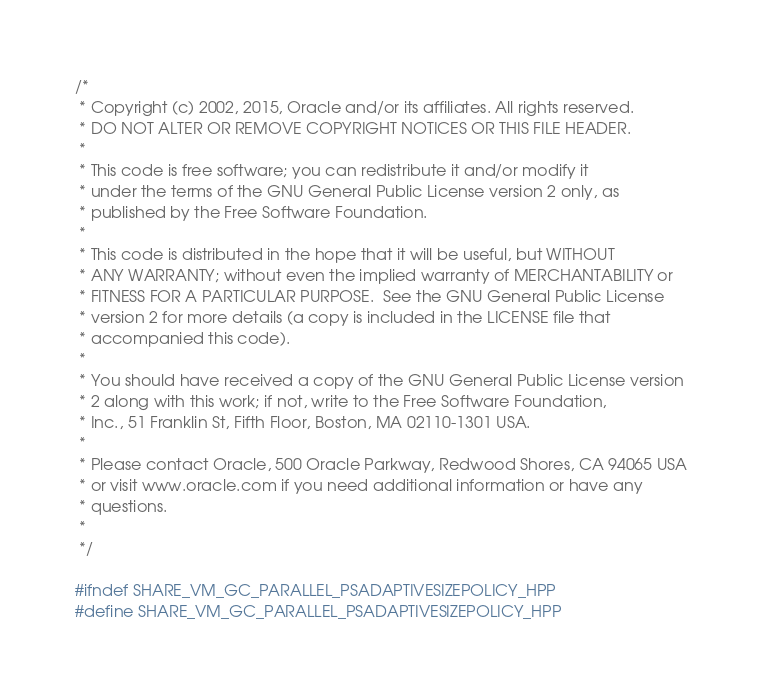<code> <loc_0><loc_0><loc_500><loc_500><_C++_>/*
 * Copyright (c) 2002, 2015, Oracle and/or its affiliates. All rights reserved.
 * DO NOT ALTER OR REMOVE COPYRIGHT NOTICES OR THIS FILE HEADER.
 *
 * This code is free software; you can redistribute it and/or modify it
 * under the terms of the GNU General Public License version 2 only, as
 * published by the Free Software Foundation.
 *
 * This code is distributed in the hope that it will be useful, but WITHOUT
 * ANY WARRANTY; without even the implied warranty of MERCHANTABILITY or
 * FITNESS FOR A PARTICULAR PURPOSE.  See the GNU General Public License
 * version 2 for more details (a copy is included in the LICENSE file that
 * accompanied this code).
 *
 * You should have received a copy of the GNU General Public License version
 * 2 along with this work; if not, write to the Free Software Foundation,
 * Inc., 51 Franklin St, Fifth Floor, Boston, MA 02110-1301 USA.
 *
 * Please contact Oracle, 500 Oracle Parkway, Redwood Shores, CA 94065 USA
 * or visit www.oracle.com if you need additional information or have any
 * questions.
 *
 */

#ifndef SHARE_VM_GC_PARALLEL_PSADAPTIVESIZEPOLICY_HPP
#define SHARE_VM_GC_PARALLEL_PSADAPTIVESIZEPOLICY_HPP
</code> 